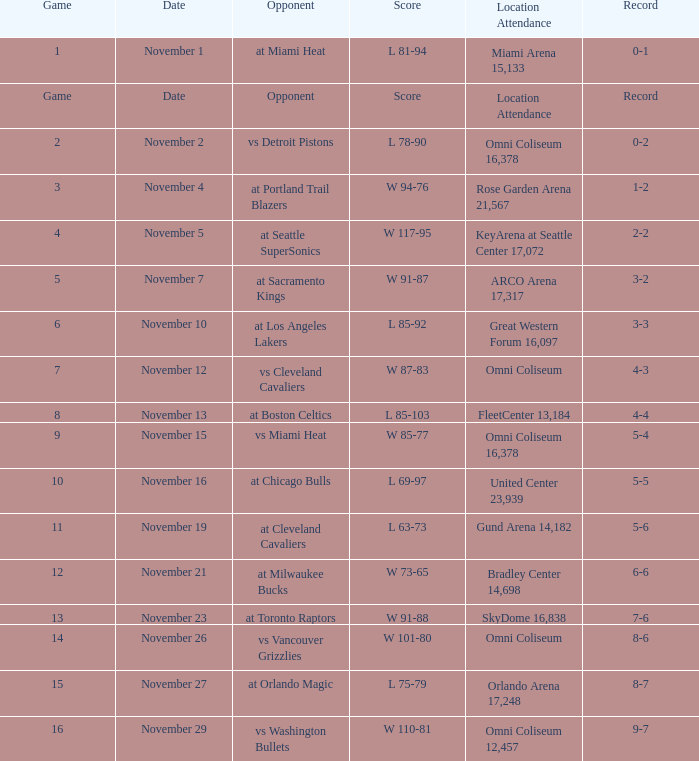What was the date of game 3? November 4. 